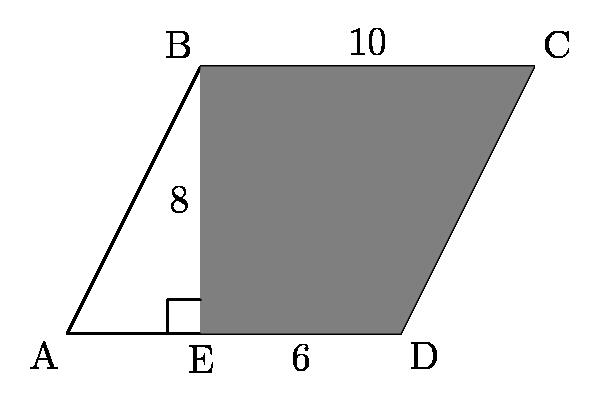How could you use this diagram to explain the relationship between parallelograms and triangles? This diagram is very useful for explaining that relationship. A parallelogram can be thought of as two congruent triangles put together side by side. In this image, if you take triangle AEB and slide it over to the other side of the parallelogram, you would overlay it perfectly onto triangle CED. This demonstrates that these two triangles are congruent, meaning they have the same size and shape. This is a visual representation of the principle that if you cut a parallelogram along one of its diagonals, you obtain two congruent triangles. 